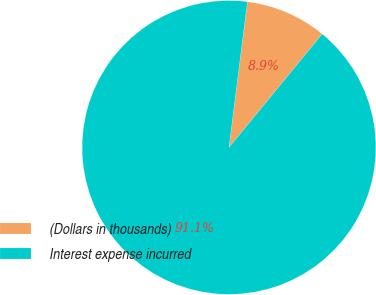Convert chart. <chart><loc_0><loc_0><loc_500><loc_500><pie_chart><fcel>(Dollars in thousands)<fcel>Interest expense incurred<nl><fcel>8.94%<fcel>91.06%<nl></chart> 